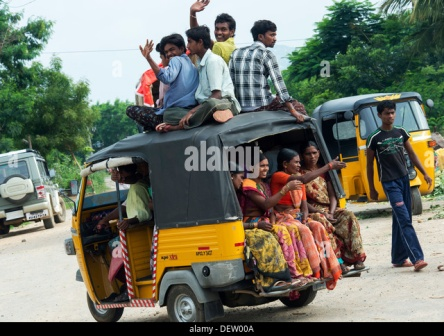Imagine this scene happening in a futuristic setting. Describe the changes you would see in the image. In this futuristic rendition, the auto rickshaw has been transformed into a sleek, solar-powered hover vehicle, effortlessly gliding a few feet above the ground. LED lights on its sides change colors to signal traffic, and the wheels are replaced with anti-gravity thrusters. The passengers are wearing lightweight, breathable suits equipped with smart technology that monitors their health and adjusts the clothing temperature accordingly.

Holographic billboards line the road, displaying advertisements and public announcements in vibrant 3D. Drone-like traffic lights hover at intersections, dynamically adjusting to the flow of hover vehicles. The trees and greenery remain, but they are interspersed with solar panels and wind turbines, generating clean energy for the community.

The sense of joy and camaraderie among the passengers remains unchanged. The young men on top of the rickshaw still wave and smile, but now they are also recording their adventure with floating camera drones that capture high-definition video from various angles. The other vehicles on the road are similarly advanced, creating a seamless blend of technology and tradition in this vibrant, futuristic landscape. 